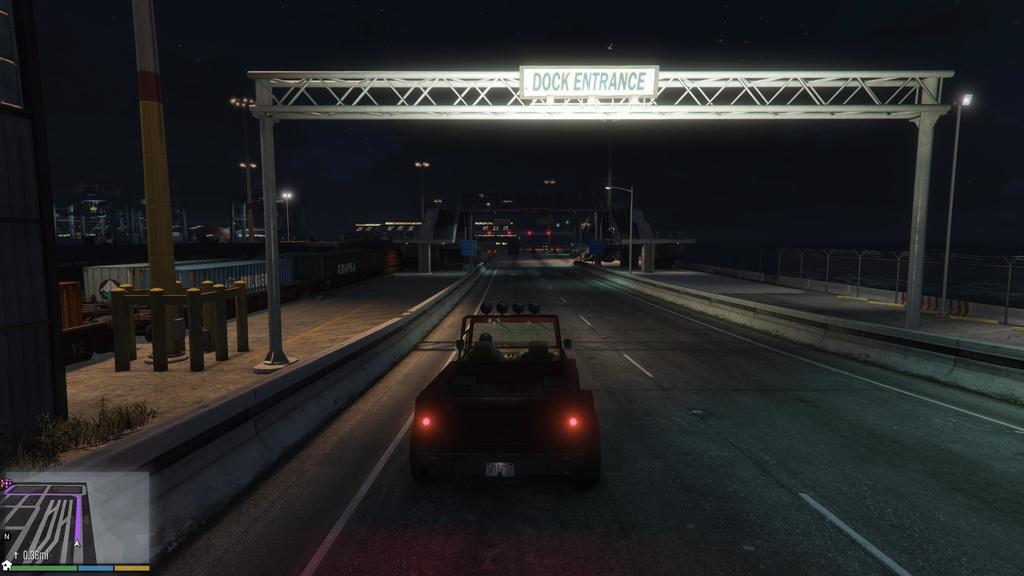How would you summarize this image in a sentence or two? This looks like a computer game. There is a vehicle in the middle. There are lights in the middle. There is something like an arch in the middle. 